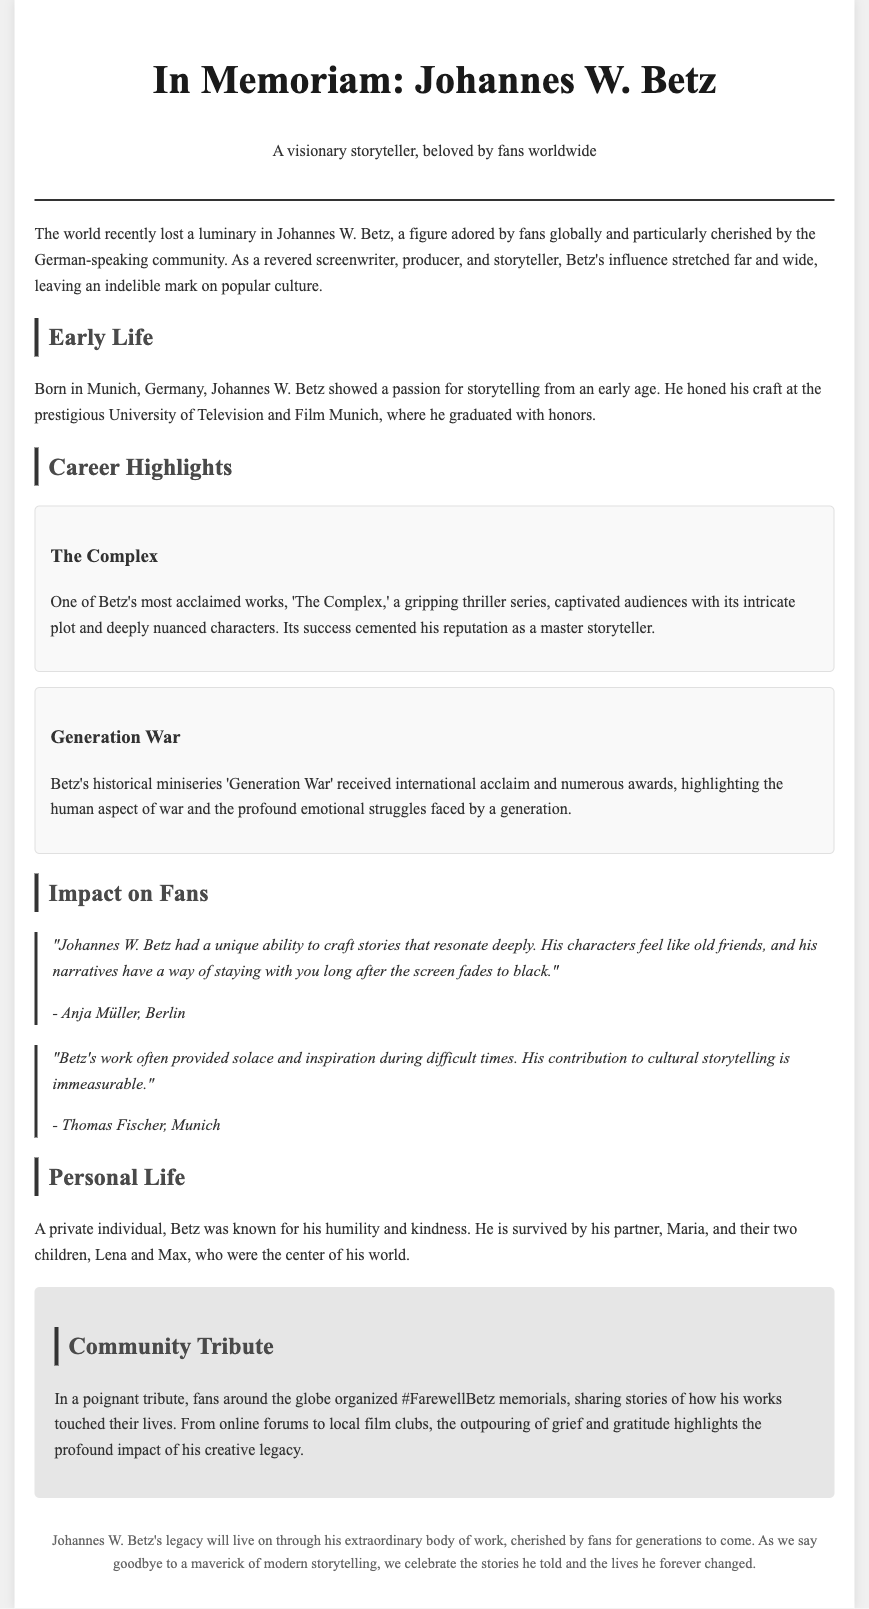What was Johannes W. Betz's profession? The document states that he was a screenwriter, producer, and storyteller.
Answer: screenwriter, producer, storyteller Where was Johannes W. Betz born? The document mentions that he was born in Munich, Germany.
Answer: Munich, Germany What notable series is mentioned as one of Betz's works? The document highlights 'The Complex' as one of his most acclaimed works.
Answer: The Complex Who organized the #FarewellBetz memorials? The memorials were organized by fans around the globe.
Answer: fans around the globe How many children did Johannes W. Betz have? The document indicates that he had two children, Lena and Max.
Answer: two What does Anja Müller describe Betz's stories as? Anja Müller notes that his characters feel like old friends.
Answer: like old friends What is the title of Betz's historical miniseries? The historical miniseries is titled 'Generation War'.
Answer: Generation War Which university did Betz graduate from? The document states that he graduated from the University of Television and Film Munich.
Answer: University of Television and Film Munich What was a key trait of Johannes W. Betz as mentioned in the document? The document describes him as a private individual known for his humility and kindness.
Answer: humility and kindness 